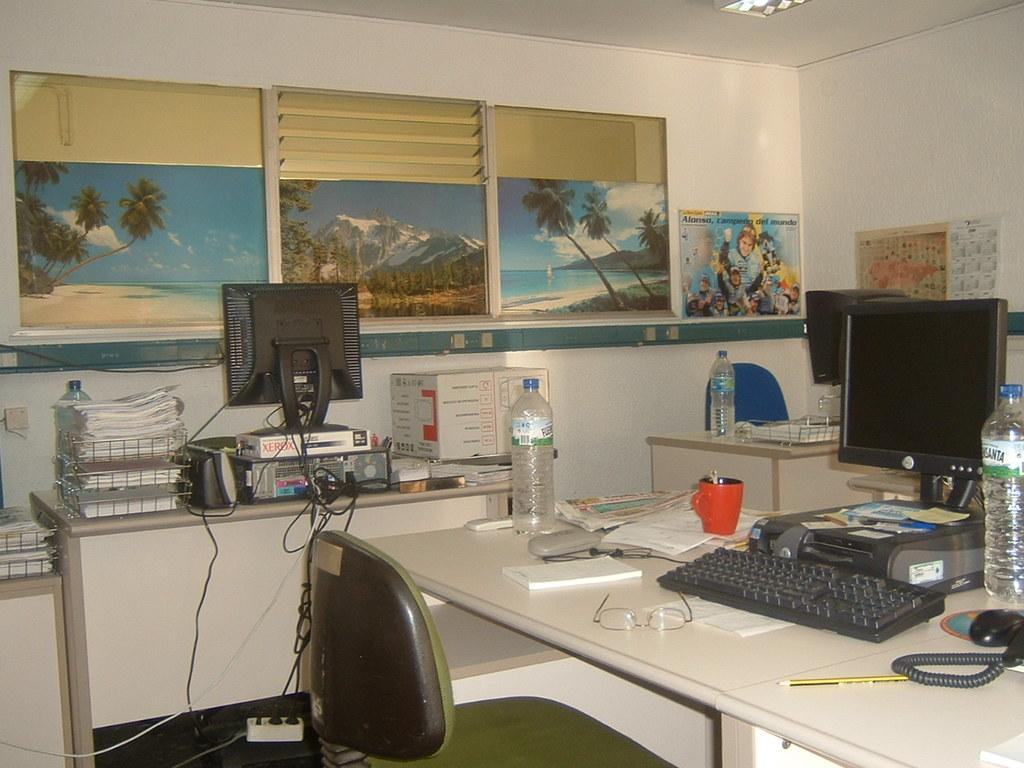What is the brand of paper stacking below the monitor on the left?
Offer a terse response. Unanswerable. 